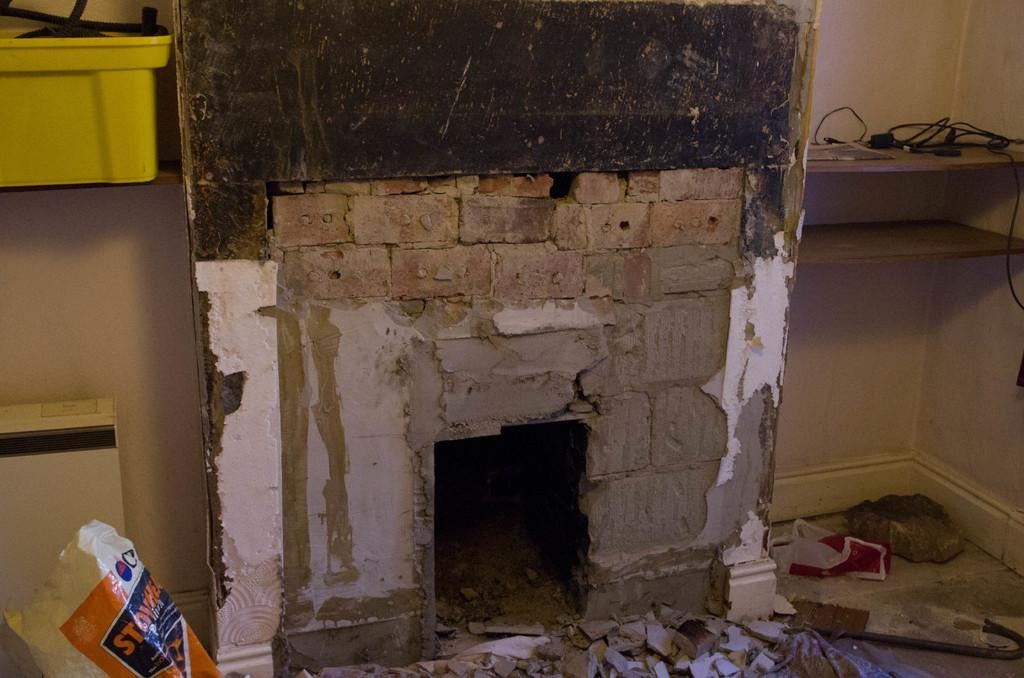What type of structure can be seen in the image? There are walls in the image. What object is present that might hold or store something? There is a container in the image. What type of electrical connections are visible in the image? Cables are visible in the image. What type of disposable item can be seen on the floor in the image? There is a polythene bag on the floor in the image. Can you describe the kiss between the two cups in the image? There are no cups or kisses present in the image. What type of existence does the image depict? The image depicts a physical scene, not an existence. 